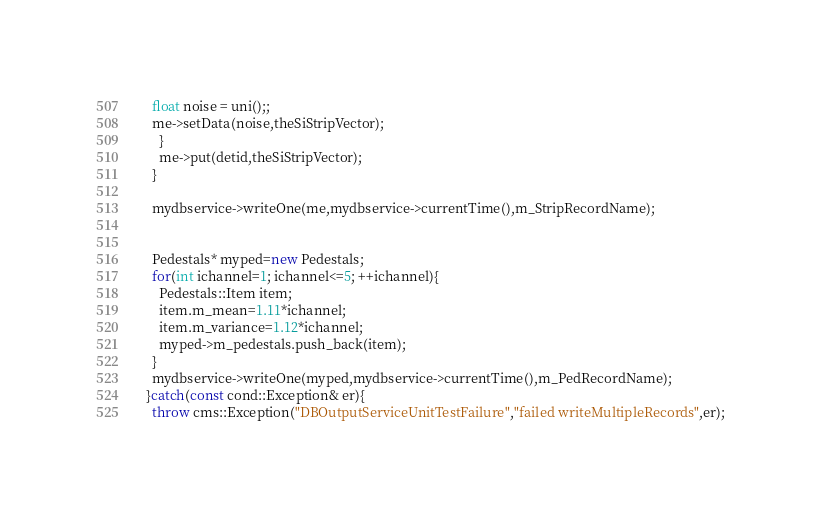<code> <loc_0><loc_0><loc_500><loc_500><_C++_>	float noise = uni();;      
	me->setData(noise,theSiStripVector);
      }
      me->put(detid,theSiStripVector);
    }
    
    mydbservice->writeOne(me,mydbservice->currentTime(),m_StripRecordName);
 
  
    Pedestals* myped=new Pedestals;
    for(int ichannel=1; ichannel<=5; ++ichannel){
      Pedestals::Item item;
      item.m_mean=1.11*ichannel;
      item.m_variance=1.12*ichannel;
      myped->m_pedestals.push_back(item);
    }
    mydbservice->writeOne(myped,mydbservice->currentTime(),m_PedRecordName);
  }catch(const cond::Exception& er){
    throw cms::Exception("DBOutputServiceUnitTestFailure","failed writeMultipleRecords",er);</code> 